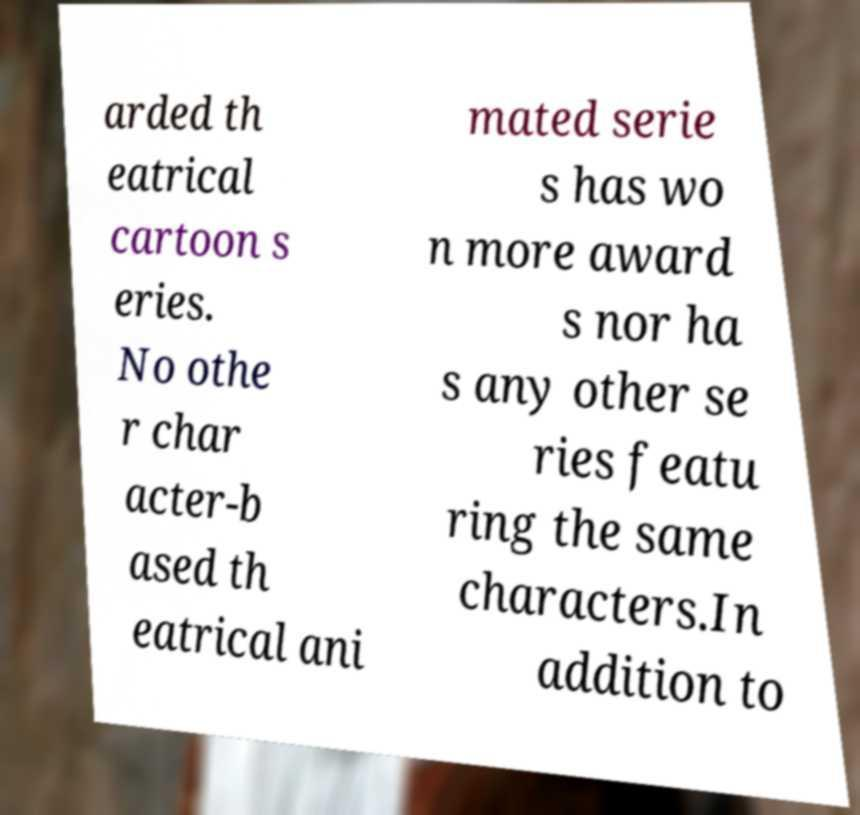Could you extract and type out the text from this image? arded th eatrical cartoon s eries. No othe r char acter-b ased th eatrical ani mated serie s has wo n more award s nor ha s any other se ries featu ring the same characters.In addition to 